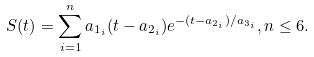Convert formula to latex. <formula><loc_0><loc_0><loc_500><loc_500>S ( t ) = \sum _ { i = 1 } ^ { n } a _ { 1 _ { i } } ( t - a _ { 2 _ { i } } ) e ^ { - ( t - a _ { 2 _ { i } } ) / a _ { 3 _ { i } } } , n \leq 6 .</formula> 